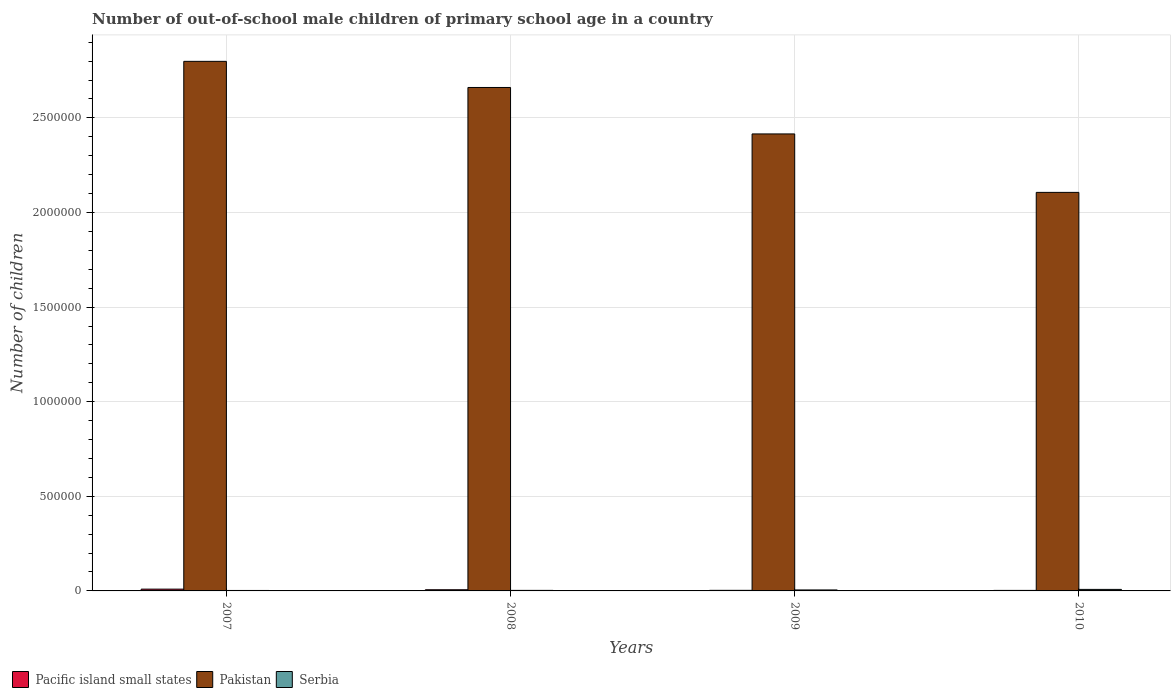How many different coloured bars are there?
Make the answer very short. 3. Are the number of bars per tick equal to the number of legend labels?
Your answer should be compact. Yes. How many bars are there on the 4th tick from the right?
Offer a very short reply. 3. What is the label of the 3rd group of bars from the left?
Provide a short and direct response. 2009. In how many cases, is the number of bars for a given year not equal to the number of legend labels?
Ensure brevity in your answer.  0. What is the number of out-of-school male children in Pakistan in 2008?
Give a very brief answer. 2.66e+06. Across all years, what is the maximum number of out-of-school male children in Serbia?
Your answer should be very brief. 8034. Across all years, what is the minimum number of out-of-school male children in Pakistan?
Give a very brief answer. 2.11e+06. In which year was the number of out-of-school male children in Serbia maximum?
Your answer should be compact. 2010. What is the total number of out-of-school male children in Serbia in the graph?
Give a very brief answer. 1.85e+04. What is the difference between the number of out-of-school male children in Serbia in 2007 and that in 2010?
Make the answer very short. -5614. What is the difference between the number of out-of-school male children in Pakistan in 2010 and the number of out-of-school male children in Pacific island small states in 2009?
Make the answer very short. 2.10e+06. What is the average number of out-of-school male children in Pakistan per year?
Provide a short and direct response. 2.50e+06. In the year 2010, what is the difference between the number of out-of-school male children in Pakistan and number of out-of-school male children in Pacific island small states?
Provide a succinct answer. 2.10e+06. What is the ratio of the number of out-of-school male children in Pakistan in 2007 to that in 2009?
Ensure brevity in your answer.  1.16. Is the difference between the number of out-of-school male children in Pakistan in 2008 and 2009 greater than the difference between the number of out-of-school male children in Pacific island small states in 2008 and 2009?
Offer a terse response. Yes. What is the difference between the highest and the second highest number of out-of-school male children in Pakistan?
Ensure brevity in your answer.  1.38e+05. What is the difference between the highest and the lowest number of out-of-school male children in Serbia?
Give a very brief answer. 5614. In how many years, is the number of out-of-school male children in Pacific island small states greater than the average number of out-of-school male children in Pacific island small states taken over all years?
Keep it short and to the point. 2. Is the sum of the number of out-of-school male children in Pacific island small states in 2008 and 2009 greater than the maximum number of out-of-school male children in Serbia across all years?
Your response must be concise. Yes. What does the 3rd bar from the left in 2010 represents?
Ensure brevity in your answer.  Serbia. What does the 1st bar from the right in 2009 represents?
Offer a very short reply. Serbia. How many bars are there?
Provide a short and direct response. 12. How many years are there in the graph?
Offer a terse response. 4. Does the graph contain any zero values?
Offer a terse response. No. Where does the legend appear in the graph?
Your answer should be compact. Bottom left. How many legend labels are there?
Your answer should be very brief. 3. What is the title of the graph?
Offer a very short reply. Number of out-of-school male children of primary school age in a country. What is the label or title of the X-axis?
Keep it short and to the point. Years. What is the label or title of the Y-axis?
Your answer should be very brief. Number of children. What is the Number of children of Pacific island small states in 2007?
Offer a terse response. 9438. What is the Number of children of Pakistan in 2007?
Keep it short and to the point. 2.80e+06. What is the Number of children in Serbia in 2007?
Your answer should be compact. 2420. What is the Number of children in Pacific island small states in 2008?
Your answer should be very brief. 6223. What is the Number of children in Pakistan in 2008?
Provide a short and direct response. 2.66e+06. What is the Number of children in Serbia in 2008?
Keep it short and to the point. 2832. What is the Number of children of Pacific island small states in 2009?
Offer a very short reply. 3078. What is the Number of children of Pakistan in 2009?
Offer a very short reply. 2.42e+06. What is the Number of children in Serbia in 2009?
Provide a short and direct response. 5199. What is the Number of children of Pacific island small states in 2010?
Offer a very short reply. 2758. What is the Number of children of Pakistan in 2010?
Make the answer very short. 2.11e+06. What is the Number of children of Serbia in 2010?
Ensure brevity in your answer.  8034. Across all years, what is the maximum Number of children of Pacific island small states?
Offer a very short reply. 9438. Across all years, what is the maximum Number of children in Pakistan?
Your response must be concise. 2.80e+06. Across all years, what is the maximum Number of children of Serbia?
Offer a very short reply. 8034. Across all years, what is the minimum Number of children in Pacific island small states?
Provide a short and direct response. 2758. Across all years, what is the minimum Number of children of Pakistan?
Your response must be concise. 2.11e+06. Across all years, what is the minimum Number of children in Serbia?
Keep it short and to the point. 2420. What is the total Number of children of Pacific island small states in the graph?
Your answer should be very brief. 2.15e+04. What is the total Number of children in Pakistan in the graph?
Provide a succinct answer. 9.98e+06. What is the total Number of children in Serbia in the graph?
Make the answer very short. 1.85e+04. What is the difference between the Number of children in Pacific island small states in 2007 and that in 2008?
Ensure brevity in your answer.  3215. What is the difference between the Number of children in Pakistan in 2007 and that in 2008?
Offer a terse response. 1.38e+05. What is the difference between the Number of children of Serbia in 2007 and that in 2008?
Offer a very short reply. -412. What is the difference between the Number of children in Pacific island small states in 2007 and that in 2009?
Ensure brevity in your answer.  6360. What is the difference between the Number of children of Pakistan in 2007 and that in 2009?
Ensure brevity in your answer.  3.84e+05. What is the difference between the Number of children of Serbia in 2007 and that in 2009?
Your response must be concise. -2779. What is the difference between the Number of children in Pacific island small states in 2007 and that in 2010?
Your answer should be compact. 6680. What is the difference between the Number of children in Pakistan in 2007 and that in 2010?
Offer a terse response. 6.92e+05. What is the difference between the Number of children in Serbia in 2007 and that in 2010?
Provide a succinct answer. -5614. What is the difference between the Number of children of Pacific island small states in 2008 and that in 2009?
Offer a terse response. 3145. What is the difference between the Number of children of Pakistan in 2008 and that in 2009?
Ensure brevity in your answer.  2.45e+05. What is the difference between the Number of children of Serbia in 2008 and that in 2009?
Make the answer very short. -2367. What is the difference between the Number of children in Pacific island small states in 2008 and that in 2010?
Provide a short and direct response. 3465. What is the difference between the Number of children of Pakistan in 2008 and that in 2010?
Keep it short and to the point. 5.54e+05. What is the difference between the Number of children in Serbia in 2008 and that in 2010?
Keep it short and to the point. -5202. What is the difference between the Number of children of Pacific island small states in 2009 and that in 2010?
Make the answer very short. 320. What is the difference between the Number of children in Pakistan in 2009 and that in 2010?
Make the answer very short. 3.09e+05. What is the difference between the Number of children of Serbia in 2009 and that in 2010?
Your answer should be very brief. -2835. What is the difference between the Number of children in Pacific island small states in 2007 and the Number of children in Pakistan in 2008?
Offer a very short reply. -2.65e+06. What is the difference between the Number of children of Pacific island small states in 2007 and the Number of children of Serbia in 2008?
Make the answer very short. 6606. What is the difference between the Number of children of Pakistan in 2007 and the Number of children of Serbia in 2008?
Give a very brief answer. 2.80e+06. What is the difference between the Number of children of Pacific island small states in 2007 and the Number of children of Pakistan in 2009?
Ensure brevity in your answer.  -2.41e+06. What is the difference between the Number of children of Pacific island small states in 2007 and the Number of children of Serbia in 2009?
Your answer should be very brief. 4239. What is the difference between the Number of children of Pakistan in 2007 and the Number of children of Serbia in 2009?
Provide a succinct answer. 2.79e+06. What is the difference between the Number of children of Pacific island small states in 2007 and the Number of children of Pakistan in 2010?
Offer a very short reply. -2.10e+06. What is the difference between the Number of children in Pacific island small states in 2007 and the Number of children in Serbia in 2010?
Your answer should be very brief. 1404. What is the difference between the Number of children in Pakistan in 2007 and the Number of children in Serbia in 2010?
Your answer should be very brief. 2.79e+06. What is the difference between the Number of children of Pacific island small states in 2008 and the Number of children of Pakistan in 2009?
Your response must be concise. -2.41e+06. What is the difference between the Number of children in Pacific island small states in 2008 and the Number of children in Serbia in 2009?
Your response must be concise. 1024. What is the difference between the Number of children in Pakistan in 2008 and the Number of children in Serbia in 2009?
Your answer should be very brief. 2.66e+06. What is the difference between the Number of children in Pacific island small states in 2008 and the Number of children in Pakistan in 2010?
Your response must be concise. -2.10e+06. What is the difference between the Number of children of Pacific island small states in 2008 and the Number of children of Serbia in 2010?
Provide a short and direct response. -1811. What is the difference between the Number of children of Pakistan in 2008 and the Number of children of Serbia in 2010?
Offer a very short reply. 2.65e+06. What is the difference between the Number of children of Pacific island small states in 2009 and the Number of children of Pakistan in 2010?
Your answer should be compact. -2.10e+06. What is the difference between the Number of children of Pacific island small states in 2009 and the Number of children of Serbia in 2010?
Give a very brief answer. -4956. What is the difference between the Number of children in Pakistan in 2009 and the Number of children in Serbia in 2010?
Keep it short and to the point. 2.41e+06. What is the average Number of children in Pacific island small states per year?
Offer a very short reply. 5374.25. What is the average Number of children in Pakistan per year?
Ensure brevity in your answer.  2.50e+06. What is the average Number of children of Serbia per year?
Give a very brief answer. 4621.25. In the year 2007, what is the difference between the Number of children in Pacific island small states and Number of children in Pakistan?
Keep it short and to the point. -2.79e+06. In the year 2007, what is the difference between the Number of children in Pacific island small states and Number of children in Serbia?
Give a very brief answer. 7018. In the year 2007, what is the difference between the Number of children of Pakistan and Number of children of Serbia?
Keep it short and to the point. 2.80e+06. In the year 2008, what is the difference between the Number of children in Pacific island small states and Number of children in Pakistan?
Your answer should be very brief. -2.65e+06. In the year 2008, what is the difference between the Number of children of Pacific island small states and Number of children of Serbia?
Ensure brevity in your answer.  3391. In the year 2008, what is the difference between the Number of children in Pakistan and Number of children in Serbia?
Provide a short and direct response. 2.66e+06. In the year 2009, what is the difference between the Number of children of Pacific island small states and Number of children of Pakistan?
Provide a succinct answer. -2.41e+06. In the year 2009, what is the difference between the Number of children in Pacific island small states and Number of children in Serbia?
Provide a short and direct response. -2121. In the year 2009, what is the difference between the Number of children of Pakistan and Number of children of Serbia?
Your answer should be very brief. 2.41e+06. In the year 2010, what is the difference between the Number of children of Pacific island small states and Number of children of Pakistan?
Keep it short and to the point. -2.10e+06. In the year 2010, what is the difference between the Number of children in Pacific island small states and Number of children in Serbia?
Give a very brief answer. -5276. In the year 2010, what is the difference between the Number of children in Pakistan and Number of children in Serbia?
Offer a terse response. 2.10e+06. What is the ratio of the Number of children of Pacific island small states in 2007 to that in 2008?
Make the answer very short. 1.52. What is the ratio of the Number of children of Pakistan in 2007 to that in 2008?
Give a very brief answer. 1.05. What is the ratio of the Number of children of Serbia in 2007 to that in 2008?
Your answer should be very brief. 0.85. What is the ratio of the Number of children in Pacific island small states in 2007 to that in 2009?
Provide a short and direct response. 3.07. What is the ratio of the Number of children in Pakistan in 2007 to that in 2009?
Ensure brevity in your answer.  1.16. What is the ratio of the Number of children in Serbia in 2007 to that in 2009?
Your response must be concise. 0.47. What is the ratio of the Number of children in Pacific island small states in 2007 to that in 2010?
Your answer should be very brief. 3.42. What is the ratio of the Number of children of Pakistan in 2007 to that in 2010?
Your response must be concise. 1.33. What is the ratio of the Number of children of Serbia in 2007 to that in 2010?
Your response must be concise. 0.3. What is the ratio of the Number of children of Pacific island small states in 2008 to that in 2009?
Make the answer very short. 2.02. What is the ratio of the Number of children of Pakistan in 2008 to that in 2009?
Offer a terse response. 1.1. What is the ratio of the Number of children of Serbia in 2008 to that in 2009?
Your answer should be very brief. 0.54. What is the ratio of the Number of children of Pacific island small states in 2008 to that in 2010?
Provide a succinct answer. 2.26. What is the ratio of the Number of children of Pakistan in 2008 to that in 2010?
Ensure brevity in your answer.  1.26. What is the ratio of the Number of children of Serbia in 2008 to that in 2010?
Your answer should be compact. 0.35. What is the ratio of the Number of children of Pacific island small states in 2009 to that in 2010?
Ensure brevity in your answer.  1.12. What is the ratio of the Number of children in Pakistan in 2009 to that in 2010?
Your answer should be very brief. 1.15. What is the ratio of the Number of children of Serbia in 2009 to that in 2010?
Provide a succinct answer. 0.65. What is the difference between the highest and the second highest Number of children of Pacific island small states?
Your answer should be compact. 3215. What is the difference between the highest and the second highest Number of children in Pakistan?
Keep it short and to the point. 1.38e+05. What is the difference between the highest and the second highest Number of children in Serbia?
Provide a short and direct response. 2835. What is the difference between the highest and the lowest Number of children of Pacific island small states?
Keep it short and to the point. 6680. What is the difference between the highest and the lowest Number of children of Pakistan?
Offer a very short reply. 6.92e+05. What is the difference between the highest and the lowest Number of children of Serbia?
Provide a succinct answer. 5614. 